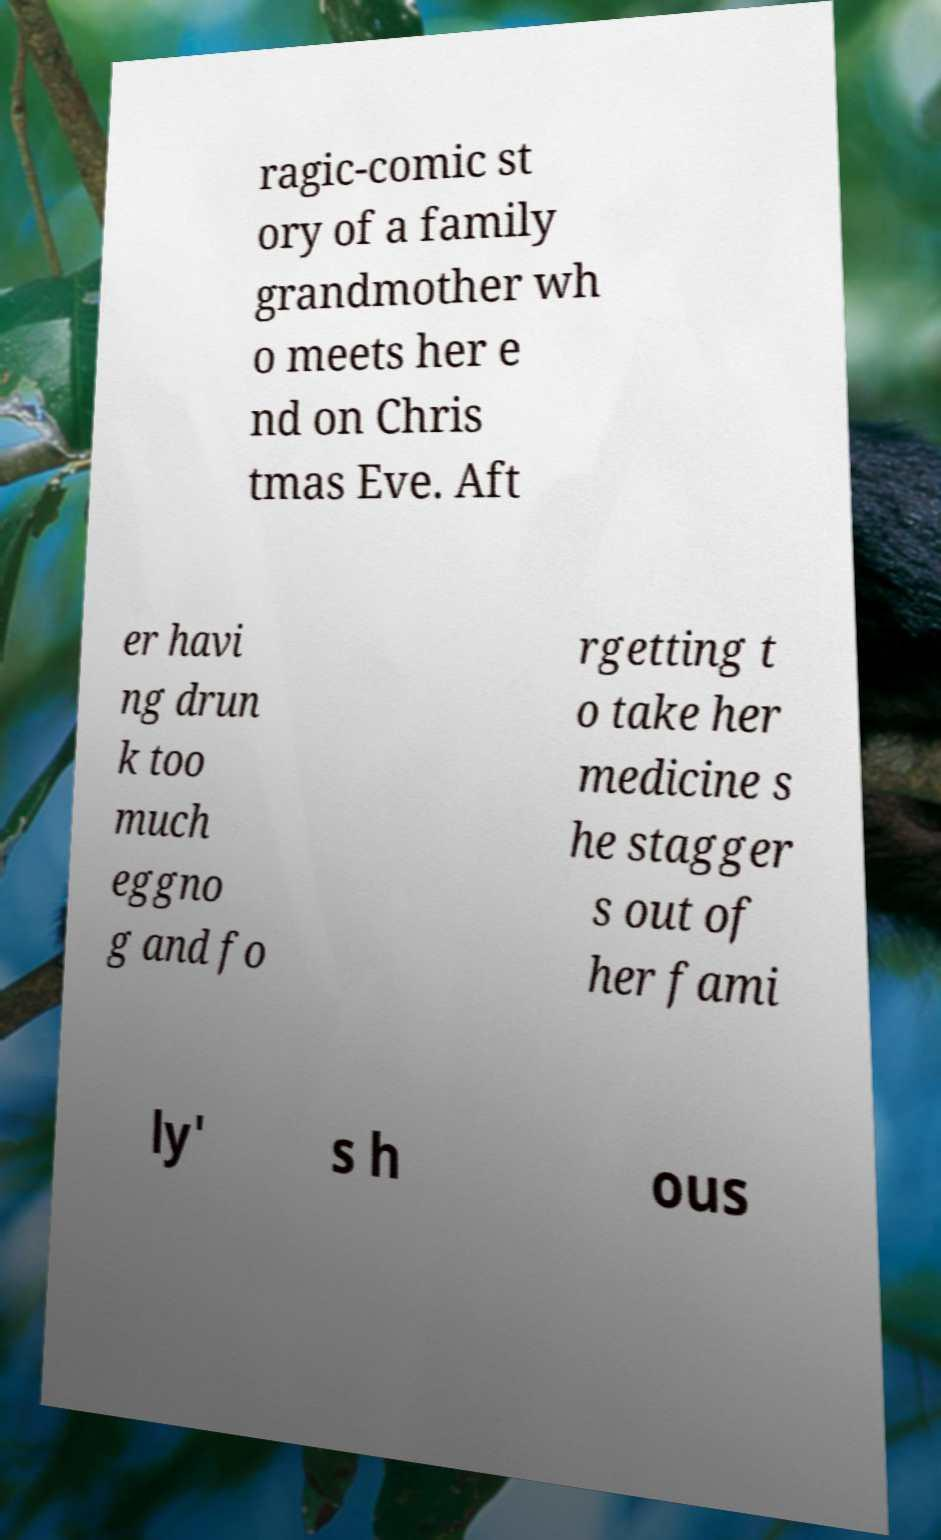Could you assist in decoding the text presented in this image and type it out clearly? ragic-comic st ory of a family grandmother wh o meets her e nd on Chris tmas Eve. Aft er havi ng drun k too much eggno g and fo rgetting t o take her medicine s he stagger s out of her fami ly' s h ous 